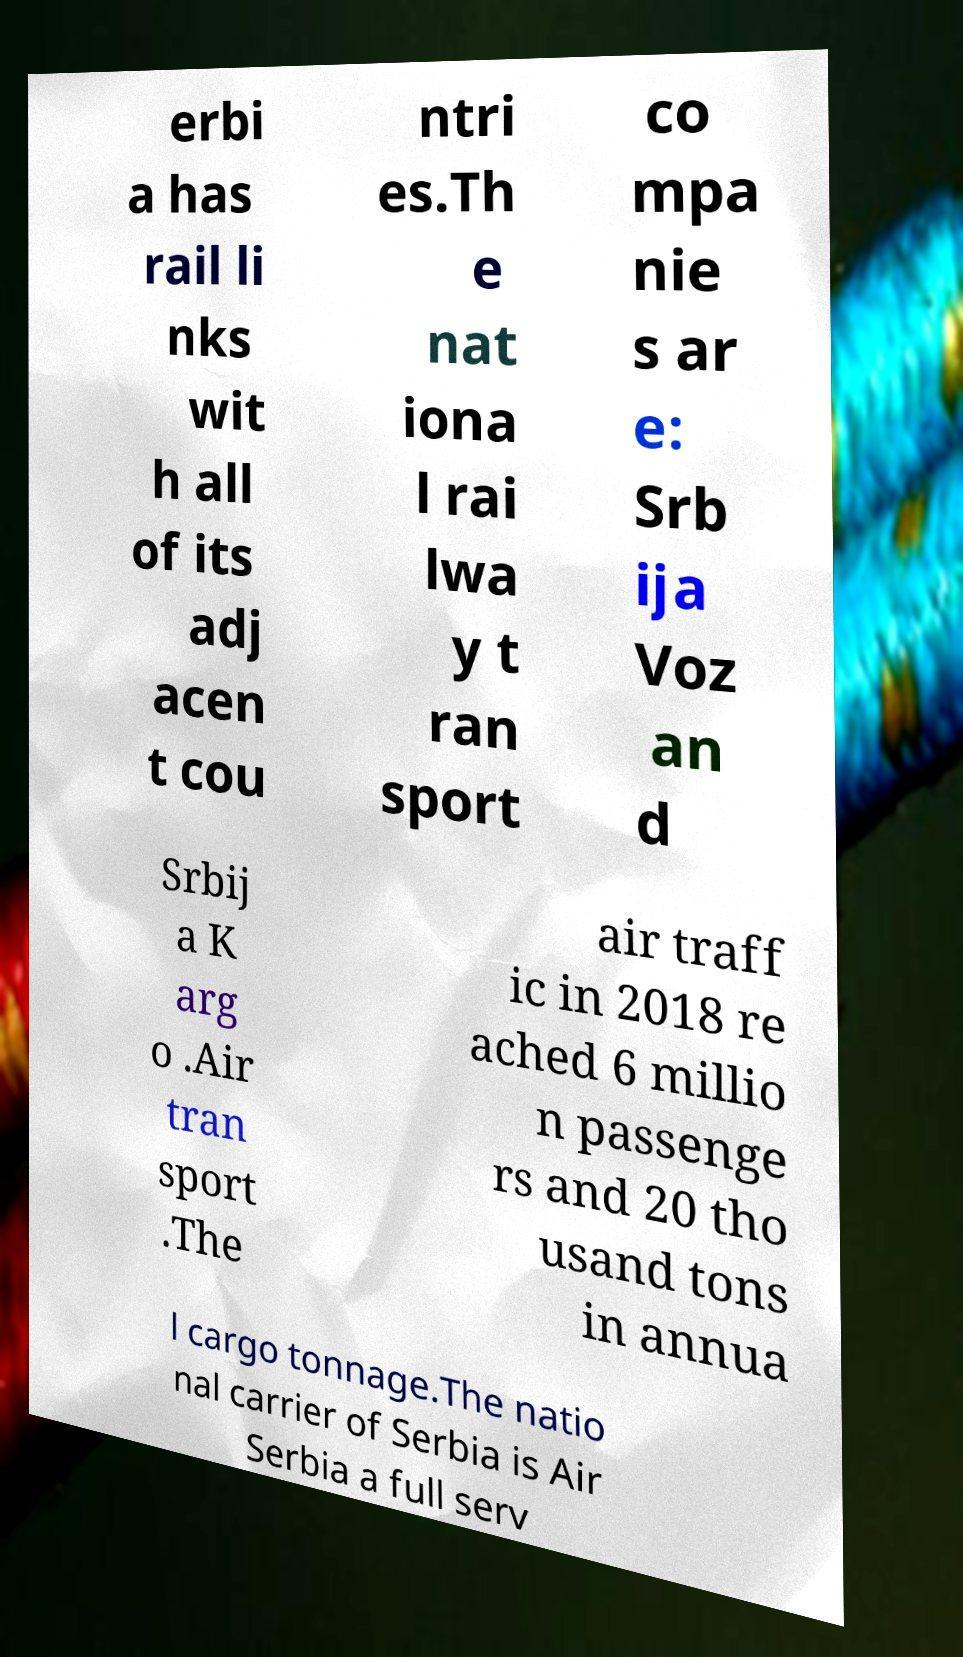Can you accurately transcribe the text from the provided image for me? erbi a has rail li nks wit h all of its adj acen t cou ntri es.Th e nat iona l rai lwa y t ran sport co mpa nie s ar e: Srb ija Voz an d Srbij a K arg o .Air tran sport .The air traff ic in 2018 re ached 6 millio n passenge rs and 20 tho usand tons in annua l cargo tonnage.The natio nal carrier of Serbia is Air Serbia a full serv 